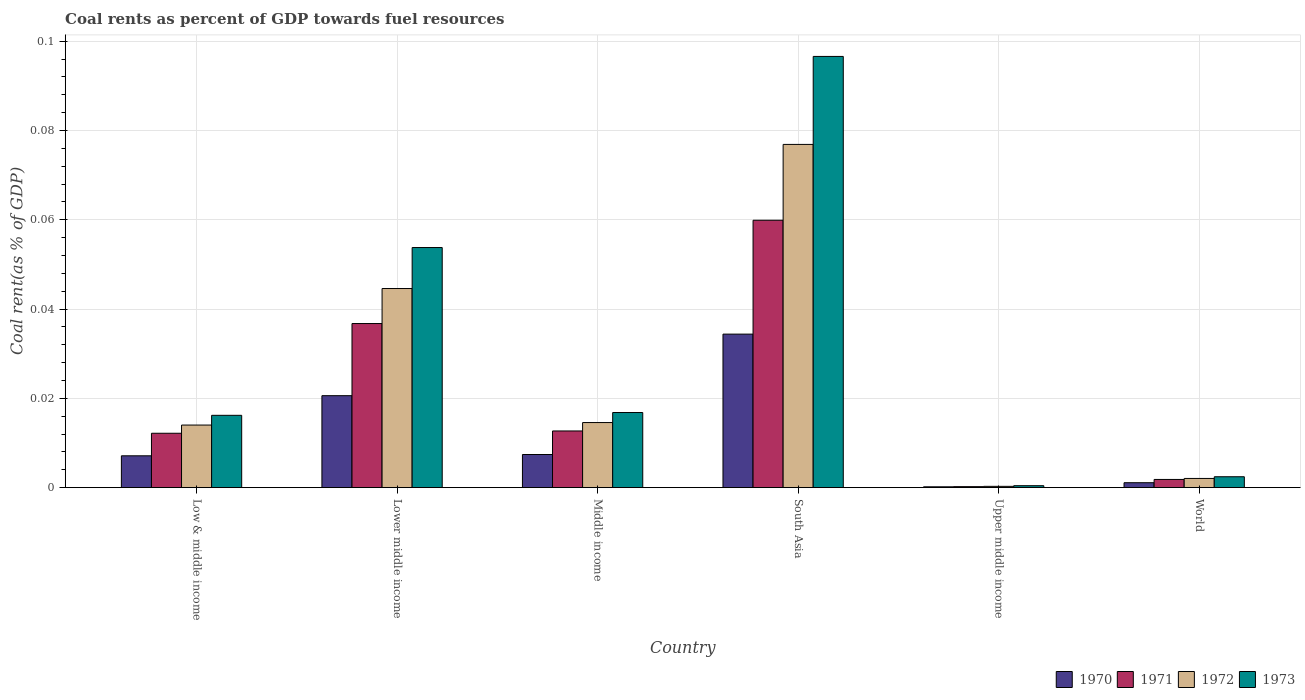How many different coloured bars are there?
Your response must be concise. 4. Are the number of bars per tick equal to the number of legend labels?
Provide a succinct answer. Yes. Are the number of bars on each tick of the X-axis equal?
Your answer should be compact. Yes. What is the label of the 5th group of bars from the left?
Keep it short and to the point. Upper middle income. What is the coal rent in 1970 in Lower middle income?
Make the answer very short. 0.02. Across all countries, what is the maximum coal rent in 1972?
Provide a succinct answer. 0.08. Across all countries, what is the minimum coal rent in 1973?
Your response must be concise. 0. In which country was the coal rent in 1973 minimum?
Offer a very short reply. Upper middle income. What is the total coal rent in 1971 in the graph?
Your response must be concise. 0.12. What is the difference between the coal rent in 1973 in Middle income and that in South Asia?
Keep it short and to the point. -0.08. What is the difference between the coal rent in 1972 in World and the coal rent in 1970 in South Asia?
Your response must be concise. -0.03. What is the average coal rent in 1971 per country?
Offer a very short reply. 0.02. What is the difference between the coal rent of/in 1971 and coal rent of/in 1970 in World?
Provide a succinct answer. 0. What is the ratio of the coal rent in 1971 in South Asia to that in World?
Your response must be concise. 32.69. Is the difference between the coal rent in 1971 in Lower middle income and Middle income greater than the difference between the coal rent in 1970 in Lower middle income and Middle income?
Your answer should be compact. Yes. What is the difference between the highest and the second highest coal rent in 1973?
Offer a terse response. 0.08. What is the difference between the highest and the lowest coal rent in 1971?
Provide a short and direct response. 0.06. Is the sum of the coal rent in 1970 in South Asia and Upper middle income greater than the maximum coal rent in 1973 across all countries?
Offer a terse response. No. Is it the case that in every country, the sum of the coal rent in 1972 and coal rent in 1970 is greater than the sum of coal rent in 1973 and coal rent in 1971?
Offer a very short reply. No. What does the 1st bar from the right in Middle income represents?
Provide a succinct answer. 1973. How many countries are there in the graph?
Your answer should be compact. 6. What is the difference between two consecutive major ticks on the Y-axis?
Offer a very short reply. 0.02. Does the graph contain any zero values?
Provide a short and direct response. No. How are the legend labels stacked?
Give a very brief answer. Horizontal. What is the title of the graph?
Give a very brief answer. Coal rents as percent of GDP towards fuel resources. What is the label or title of the X-axis?
Your answer should be compact. Country. What is the label or title of the Y-axis?
Make the answer very short. Coal rent(as % of GDP). What is the Coal rent(as % of GDP) of 1970 in Low & middle income?
Your answer should be compact. 0.01. What is the Coal rent(as % of GDP) in 1971 in Low & middle income?
Give a very brief answer. 0.01. What is the Coal rent(as % of GDP) of 1972 in Low & middle income?
Your response must be concise. 0.01. What is the Coal rent(as % of GDP) in 1973 in Low & middle income?
Make the answer very short. 0.02. What is the Coal rent(as % of GDP) in 1970 in Lower middle income?
Offer a very short reply. 0.02. What is the Coal rent(as % of GDP) in 1971 in Lower middle income?
Keep it short and to the point. 0.04. What is the Coal rent(as % of GDP) in 1972 in Lower middle income?
Provide a succinct answer. 0.04. What is the Coal rent(as % of GDP) of 1973 in Lower middle income?
Provide a short and direct response. 0.05. What is the Coal rent(as % of GDP) in 1970 in Middle income?
Give a very brief answer. 0.01. What is the Coal rent(as % of GDP) of 1971 in Middle income?
Offer a very short reply. 0.01. What is the Coal rent(as % of GDP) in 1972 in Middle income?
Provide a succinct answer. 0.01. What is the Coal rent(as % of GDP) of 1973 in Middle income?
Your response must be concise. 0.02. What is the Coal rent(as % of GDP) in 1970 in South Asia?
Keep it short and to the point. 0.03. What is the Coal rent(as % of GDP) in 1971 in South Asia?
Give a very brief answer. 0.06. What is the Coal rent(as % of GDP) of 1972 in South Asia?
Ensure brevity in your answer.  0.08. What is the Coal rent(as % of GDP) in 1973 in South Asia?
Provide a succinct answer. 0.1. What is the Coal rent(as % of GDP) of 1970 in Upper middle income?
Your response must be concise. 0. What is the Coal rent(as % of GDP) of 1971 in Upper middle income?
Provide a short and direct response. 0. What is the Coal rent(as % of GDP) of 1972 in Upper middle income?
Give a very brief answer. 0. What is the Coal rent(as % of GDP) of 1973 in Upper middle income?
Offer a very short reply. 0. What is the Coal rent(as % of GDP) of 1970 in World?
Offer a very short reply. 0. What is the Coal rent(as % of GDP) in 1971 in World?
Offer a terse response. 0. What is the Coal rent(as % of GDP) of 1972 in World?
Provide a succinct answer. 0. What is the Coal rent(as % of GDP) in 1973 in World?
Give a very brief answer. 0. Across all countries, what is the maximum Coal rent(as % of GDP) in 1970?
Provide a succinct answer. 0.03. Across all countries, what is the maximum Coal rent(as % of GDP) in 1971?
Keep it short and to the point. 0.06. Across all countries, what is the maximum Coal rent(as % of GDP) of 1972?
Your response must be concise. 0.08. Across all countries, what is the maximum Coal rent(as % of GDP) of 1973?
Keep it short and to the point. 0.1. Across all countries, what is the minimum Coal rent(as % of GDP) in 1970?
Provide a succinct answer. 0. Across all countries, what is the minimum Coal rent(as % of GDP) of 1971?
Your answer should be very brief. 0. Across all countries, what is the minimum Coal rent(as % of GDP) in 1972?
Keep it short and to the point. 0. Across all countries, what is the minimum Coal rent(as % of GDP) of 1973?
Offer a terse response. 0. What is the total Coal rent(as % of GDP) of 1970 in the graph?
Make the answer very short. 0.07. What is the total Coal rent(as % of GDP) in 1971 in the graph?
Provide a succinct answer. 0.12. What is the total Coal rent(as % of GDP) in 1972 in the graph?
Provide a short and direct response. 0.15. What is the total Coal rent(as % of GDP) in 1973 in the graph?
Your response must be concise. 0.19. What is the difference between the Coal rent(as % of GDP) in 1970 in Low & middle income and that in Lower middle income?
Provide a short and direct response. -0.01. What is the difference between the Coal rent(as % of GDP) of 1971 in Low & middle income and that in Lower middle income?
Provide a short and direct response. -0.02. What is the difference between the Coal rent(as % of GDP) in 1972 in Low & middle income and that in Lower middle income?
Your response must be concise. -0.03. What is the difference between the Coal rent(as % of GDP) in 1973 in Low & middle income and that in Lower middle income?
Give a very brief answer. -0.04. What is the difference between the Coal rent(as % of GDP) of 1970 in Low & middle income and that in Middle income?
Make the answer very short. -0. What is the difference between the Coal rent(as % of GDP) in 1971 in Low & middle income and that in Middle income?
Offer a terse response. -0. What is the difference between the Coal rent(as % of GDP) of 1972 in Low & middle income and that in Middle income?
Your response must be concise. -0. What is the difference between the Coal rent(as % of GDP) of 1973 in Low & middle income and that in Middle income?
Offer a very short reply. -0. What is the difference between the Coal rent(as % of GDP) of 1970 in Low & middle income and that in South Asia?
Give a very brief answer. -0.03. What is the difference between the Coal rent(as % of GDP) in 1971 in Low & middle income and that in South Asia?
Offer a very short reply. -0.05. What is the difference between the Coal rent(as % of GDP) in 1972 in Low & middle income and that in South Asia?
Offer a very short reply. -0.06. What is the difference between the Coal rent(as % of GDP) in 1973 in Low & middle income and that in South Asia?
Your answer should be compact. -0.08. What is the difference between the Coal rent(as % of GDP) of 1970 in Low & middle income and that in Upper middle income?
Ensure brevity in your answer.  0.01. What is the difference between the Coal rent(as % of GDP) of 1971 in Low & middle income and that in Upper middle income?
Your answer should be very brief. 0.01. What is the difference between the Coal rent(as % of GDP) in 1972 in Low & middle income and that in Upper middle income?
Your answer should be very brief. 0.01. What is the difference between the Coal rent(as % of GDP) in 1973 in Low & middle income and that in Upper middle income?
Your answer should be compact. 0.02. What is the difference between the Coal rent(as % of GDP) of 1970 in Low & middle income and that in World?
Give a very brief answer. 0.01. What is the difference between the Coal rent(as % of GDP) in 1971 in Low & middle income and that in World?
Provide a short and direct response. 0.01. What is the difference between the Coal rent(as % of GDP) of 1972 in Low & middle income and that in World?
Provide a succinct answer. 0.01. What is the difference between the Coal rent(as % of GDP) in 1973 in Low & middle income and that in World?
Provide a short and direct response. 0.01. What is the difference between the Coal rent(as % of GDP) in 1970 in Lower middle income and that in Middle income?
Your answer should be very brief. 0.01. What is the difference between the Coal rent(as % of GDP) in 1971 in Lower middle income and that in Middle income?
Ensure brevity in your answer.  0.02. What is the difference between the Coal rent(as % of GDP) of 1973 in Lower middle income and that in Middle income?
Your answer should be very brief. 0.04. What is the difference between the Coal rent(as % of GDP) of 1970 in Lower middle income and that in South Asia?
Keep it short and to the point. -0.01. What is the difference between the Coal rent(as % of GDP) of 1971 in Lower middle income and that in South Asia?
Your answer should be very brief. -0.02. What is the difference between the Coal rent(as % of GDP) in 1972 in Lower middle income and that in South Asia?
Ensure brevity in your answer.  -0.03. What is the difference between the Coal rent(as % of GDP) of 1973 in Lower middle income and that in South Asia?
Keep it short and to the point. -0.04. What is the difference between the Coal rent(as % of GDP) of 1970 in Lower middle income and that in Upper middle income?
Offer a very short reply. 0.02. What is the difference between the Coal rent(as % of GDP) in 1971 in Lower middle income and that in Upper middle income?
Make the answer very short. 0.04. What is the difference between the Coal rent(as % of GDP) in 1972 in Lower middle income and that in Upper middle income?
Provide a succinct answer. 0.04. What is the difference between the Coal rent(as % of GDP) of 1973 in Lower middle income and that in Upper middle income?
Provide a short and direct response. 0.05. What is the difference between the Coal rent(as % of GDP) of 1970 in Lower middle income and that in World?
Ensure brevity in your answer.  0.02. What is the difference between the Coal rent(as % of GDP) of 1971 in Lower middle income and that in World?
Ensure brevity in your answer.  0.03. What is the difference between the Coal rent(as % of GDP) in 1972 in Lower middle income and that in World?
Your answer should be compact. 0.04. What is the difference between the Coal rent(as % of GDP) in 1973 in Lower middle income and that in World?
Provide a succinct answer. 0.05. What is the difference between the Coal rent(as % of GDP) of 1970 in Middle income and that in South Asia?
Provide a short and direct response. -0.03. What is the difference between the Coal rent(as % of GDP) of 1971 in Middle income and that in South Asia?
Your response must be concise. -0.05. What is the difference between the Coal rent(as % of GDP) of 1972 in Middle income and that in South Asia?
Offer a terse response. -0.06. What is the difference between the Coal rent(as % of GDP) of 1973 in Middle income and that in South Asia?
Your answer should be very brief. -0.08. What is the difference between the Coal rent(as % of GDP) in 1970 in Middle income and that in Upper middle income?
Your response must be concise. 0.01. What is the difference between the Coal rent(as % of GDP) in 1971 in Middle income and that in Upper middle income?
Your response must be concise. 0.01. What is the difference between the Coal rent(as % of GDP) in 1972 in Middle income and that in Upper middle income?
Give a very brief answer. 0.01. What is the difference between the Coal rent(as % of GDP) in 1973 in Middle income and that in Upper middle income?
Offer a terse response. 0.02. What is the difference between the Coal rent(as % of GDP) of 1970 in Middle income and that in World?
Your answer should be compact. 0.01. What is the difference between the Coal rent(as % of GDP) in 1971 in Middle income and that in World?
Offer a terse response. 0.01. What is the difference between the Coal rent(as % of GDP) of 1972 in Middle income and that in World?
Make the answer very short. 0.01. What is the difference between the Coal rent(as % of GDP) in 1973 in Middle income and that in World?
Provide a succinct answer. 0.01. What is the difference between the Coal rent(as % of GDP) in 1970 in South Asia and that in Upper middle income?
Keep it short and to the point. 0.03. What is the difference between the Coal rent(as % of GDP) in 1971 in South Asia and that in Upper middle income?
Make the answer very short. 0.06. What is the difference between the Coal rent(as % of GDP) of 1972 in South Asia and that in Upper middle income?
Your answer should be compact. 0.08. What is the difference between the Coal rent(as % of GDP) in 1973 in South Asia and that in Upper middle income?
Make the answer very short. 0.1. What is the difference between the Coal rent(as % of GDP) in 1971 in South Asia and that in World?
Ensure brevity in your answer.  0.06. What is the difference between the Coal rent(as % of GDP) in 1972 in South Asia and that in World?
Offer a terse response. 0.07. What is the difference between the Coal rent(as % of GDP) of 1973 in South Asia and that in World?
Provide a short and direct response. 0.09. What is the difference between the Coal rent(as % of GDP) of 1970 in Upper middle income and that in World?
Ensure brevity in your answer.  -0. What is the difference between the Coal rent(as % of GDP) in 1971 in Upper middle income and that in World?
Give a very brief answer. -0. What is the difference between the Coal rent(as % of GDP) in 1972 in Upper middle income and that in World?
Your answer should be very brief. -0. What is the difference between the Coal rent(as % of GDP) of 1973 in Upper middle income and that in World?
Provide a succinct answer. -0. What is the difference between the Coal rent(as % of GDP) of 1970 in Low & middle income and the Coal rent(as % of GDP) of 1971 in Lower middle income?
Keep it short and to the point. -0.03. What is the difference between the Coal rent(as % of GDP) of 1970 in Low & middle income and the Coal rent(as % of GDP) of 1972 in Lower middle income?
Provide a succinct answer. -0.04. What is the difference between the Coal rent(as % of GDP) in 1970 in Low & middle income and the Coal rent(as % of GDP) in 1973 in Lower middle income?
Offer a terse response. -0.05. What is the difference between the Coal rent(as % of GDP) of 1971 in Low & middle income and the Coal rent(as % of GDP) of 1972 in Lower middle income?
Keep it short and to the point. -0.03. What is the difference between the Coal rent(as % of GDP) in 1971 in Low & middle income and the Coal rent(as % of GDP) in 1973 in Lower middle income?
Your answer should be compact. -0.04. What is the difference between the Coal rent(as % of GDP) in 1972 in Low & middle income and the Coal rent(as % of GDP) in 1973 in Lower middle income?
Give a very brief answer. -0.04. What is the difference between the Coal rent(as % of GDP) in 1970 in Low & middle income and the Coal rent(as % of GDP) in 1971 in Middle income?
Your answer should be compact. -0.01. What is the difference between the Coal rent(as % of GDP) in 1970 in Low & middle income and the Coal rent(as % of GDP) in 1972 in Middle income?
Give a very brief answer. -0.01. What is the difference between the Coal rent(as % of GDP) in 1970 in Low & middle income and the Coal rent(as % of GDP) in 1973 in Middle income?
Offer a very short reply. -0.01. What is the difference between the Coal rent(as % of GDP) of 1971 in Low & middle income and the Coal rent(as % of GDP) of 1972 in Middle income?
Offer a very short reply. -0. What is the difference between the Coal rent(as % of GDP) in 1971 in Low & middle income and the Coal rent(as % of GDP) in 1973 in Middle income?
Offer a terse response. -0. What is the difference between the Coal rent(as % of GDP) of 1972 in Low & middle income and the Coal rent(as % of GDP) of 1973 in Middle income?
Your answer should be compact. -0. What is the difference between the Coal rent(as % of GDP) in 1970 in Low & middle income and the Coal rent(as % of GDP) in 1971 in South Asia?
Your answer should be very brief. -0.05. What is the difference between the Coal rent(as % of GDP) in 1970 in Low & middle income and the Coal rent(as % of GDP) in 1972 in South Asia?
Offer a very short reply. -0.07. What is the difference between the Coal rent(as % of GDP) of 1970 in Low & middle income and the Coal rent(as % of GDP) of 1973 in South Asia?
Make the answer very short. -0.09. What is the difference between the Coal rent(as % of GDP) of 1971 in Low & middle income and the Coal rent(as % of GDP) of 1972 in South Asia?
Provide a succinct answer. -0.06. What is the difference between the Coal rent(as % of GDP) in 1971 in Low & middle income and the Coal rent(as % of GDP) in 1973 in South Asia?
Offer a very short reply. -0.08. What is the difference between the Coal rent(as % of GDP) of 1972 in Low & middle income and the Coal rent(as % of GDP) of 1973 in South Asia?
Offer a very short reply. -0.08. What is the difference between the Coal rent(as % of GDP) of 1970 in Low & middle income and the Coal rent(as % of GDP) of 1971 in Upper middle income?
Your response must be concise. 0.01. What is the difference between the Coal rent(as % of GDP) of 1970 in Low & middle income and the Coal rent(as % of GDP) of 1972 in Upper middle income?
Keep it short and to the point. 0.01. What is the difference between the Coal rent(as % of GDP) of 1970 in Low & middle income and the Coal rent(as % of GDP) of 1973 in Upper middle income?
Offer a very short reply. 0.01. What is the difference between the Coal rent(as % of GDP) in 1971 in Low & middle income and the Coal rent(as % of GDP) in 1972 in Upper middle income?
Offer a terse response. 0.01. What is the difference between the Coal rent(as % of GDP) in 1971 in Low & middle income and the Coal rent(as % of GDP) in 1973 in Upper middle income?
Ensure brevity in your answer.  0.01. What is the difference between the Coal rent(as % of GDP) in 1972 in Low & middle income and the Coal rent(as % of GDP) in 1973 in Upper middle income?
Make the answer very short. 0.01. What is the difference between the Coal rent(as % of GDP) in 1970 in Low & middle income and the Coal rent(as % of GDP) in 1971 in World?
Ensure brevity in your answer.  0.01. What is the difference between the Coal rent(as % of GDP) of 1970 in Low & middle income and the Coal rent(as % of GDP) of 1972 in World?
Ensure brevity in your answer.  0.01. What is the difference between the Coal rent(as % of GDP) in 1970 in Low & middle income and the Coal rent(as % of GDP) in 1973 in World?
Your answer should be compact. 0. What is the difference between the Coal rent(as % of GDP) in 1971 in Low & middle income and the Coal rent(as % of GDP) in 1972 in World?
Provide a short and direct response. 0.01. What is the difference between the Coal rent(as % of GDP) in 1971 in Low & middle income and the Coal rent(as % of GDP) in 1973 in World?
Offer a very short reply. 0.01. What is the difference between the Coal rent(as % of GDP) of 1972 in Low & middle income and the Coal rent(as % of GDP) of 1973 in World?
Offer a very short reply. 0.01. What is the difference between the Coal rent(as % of GDP) in 1970 in Lower middle income and the Coal rent(as % of GDP) in 1971 in Middle income?
Provide a short and direct response. 0.01. What is the difference between the Coal rent(as % of GDP) in 1970 in Lower middle income and the Coal rent(as % of GDP) in 1972 in Middle income?
Your answer should be very brief. 0.01. What is the difference between the Coal rent(as % of GDP) of 1970 in Lower middle income and the Coal rent(as % of GDP) of 1973 in Middle income?
Provide a short and direct response. 0. What is the difference between the Coal rent(as % of GDP) of 1971 in Lower middle income and the Coal rent(as % of GDP) of 1972 in Middle income?
Provide a succinct answer. 0.02. What is the difference between the Coal rent(as % of GDP) in 1971 in Lower middle income and the Coal rent(as % of GDP) in 1973 in Middle income?
Offer a very short reply. 0.02. What is the difference between the Coal rent(as % of GDP) in 1972 in Lower middle income and the Coal rent(as % of GDP) in 1973 in Middle income?
Give a very brief answer. 0.03. What is the difference between the Coal rent(as % of GDP) in 1970 in Lower middle income and the Coal rent(as % of GDP) in 1971 in South Asia?
Provide a short and direct response. -0.04. What is the difference between the Coal rent(as % of GDP) in 1970 in Lower middle income and the Coal rent(as % of GDP) in 1972 in South Asia?
Offer a very short reply. -0.06. What is the difference between the Coal rent(as % of GDP) of 1970 in Lower middle income and the Coal rent(as % of GDP) of 1973 in South Asia?
Offer a very short reply. -0.08. What is the difference between the Coal rent(as % of GDP) in 1971 in Lower middle income and the Coal rent(as % of GDP) in 1972 in South Asia?
Make the answer very short. -0.04. What is the difference between the Coal rent(as % of GDP) of 1971 in Lower middle income and the Coal rent(as % of GDP) of 1973 in South Asia?
Your response must be concise. -0.06. What is the difference between the Coal rent(as % of GDP) of 1972 in Lower middle income and the Coal rent(as % of GDP) of 1973 in South Asia?
Provide a succinct answer. -0.05. What is the difference between the Coal rent(as % of GDP) of 1970 in Lower middle income and the Coal rent(as % of GDP) of 1971 in Upper middle income?
Offer a terse response. 0.02. What is the difference between the Coal rent(as % of GDP) of 1970 in Lower middle income and the Coal rent(as % of GDP) of 1972 in Upper middle income?
Provide a succinct answer. 0.02. What is the difference between the Coal rent(as % of GDP) in 1970 in Lower middle income and the Coal rent(as % of GDP) in 1973 in Upper middle income?
Keep it short and to the point. 0.02. What is the difference between the Coal rent(as % of GDP) of 1971 in Lower middle income and the Coal rent(as % of GDP) of 1972 in Upper middle income?
Ensure brevity in your answer.  0.04. What is the difference between the Coal rent(as % of GDP) of 1971 in Lower middle income and the Coal rent(as % of GDP) of 1973 in Upper middle income?
Provide a succinct answer. 0.04. What is the difference between the Coal rent(as % of GDP) in 1972 in Lower middle income and the Coal rent(as % of GDP) in 1973 in Upper middle income?
Your response must be concise. 0.04. What is the difference between the Coal rent(as % of GDP) in 1970 in Lower middle income and the Coal rent(as % of GDP) in 1971 in World?
Ensure brevity in your answer.  0.02. What is the difference between the Coal rent(as % of GDP) of 1970 in Lower middle income and the Coal rent(as % of GDP) of 1972 in World?
Offer a terse response. 0.02. What is the difference between the Coal rent(as % of GDP) in 1970 in Lower middle income and the Coal rent(as % of GDP) in 1973 in World?
Ensure brevity in your answer.  0.02. What is the difference between the Coal rent(as % of GDP) in 1971 in Lower middle income and the Coal rent(as % of GDP) in 1972 in World?
Your response must be concise. 0.03. What is the difference between the Coal rent(as % of GDP) of 1971 in Lower middle income and the Coal rent(as % of GDP) of 1973 in World?
Your answer should be very brief. 0.03. What is the difference between the Coal rent(as % of GDP) of 1972 in Lower middle income and the Coal rent(as % of GDP) of 1973 in World?
Offer a terse response. 0.04. What is the difference between the Coal rent(as % of GDP) in 1970 in Middle income and the Coal rent(as % of GDP) in 1971 in South Asia?
Your answer should be compact. -0.05. What is the difference between the Coal rent(as % of GDP) of 1970 in Middle income and the Coal rent(as % of GDP) of 1972 in South Asia?
Make the answer very short. -0.07. What is the difference between the Coal rent(as % of GDP) of 1970 in Middle income and the Coal rent(as % of GDP) of 1973 in South Asia?
Your answer should be compact. -0.09. What is the difference between the Coal rent(as % of GDP) of 1971 in Middle income and the Coal rent(as % of GDP) of 1972 in South Asia?
Ensure brevity in your answer.  -0.06. What is the difference between the Coal rent(as % of GDP) of 1971 in Middle income and the Coal rent(as % of GDP) of 1973 in South Asia?
Your answer should be compact. -0.08. What is the difference between the Coal rent(as % of GDP) of 1972 in Middle income and the Coal rent(as % of GDP) of 1973 in South Asia?
Make the answer very short. -0.08. What is the difference between the Coal rent(as % of GDP) of 1970 in Middle income and the Coal rent(as % of GDP) of 1971 in Upper middle income?
Ensure brevity in your answer.  0.01. What is the difference between the Coal rent(as % of GDP) of 1970 in Middle income and the Coal rent(as % of GDP) of 1972 in Upper middle income?
Provide a short and direct response. 0.01. What is the difference between the Coal rent(as % of GDP) in 1970 in Middle income and the Coal rent(as % of GDP) in 1973 in Upper middle income?
Your response must be concise. 0.01. What is the difference between the Coal rent(as % of GDP) of 1971 in Middle income and the Coal rent(as % of GDP) of 1972 in Upper middle income?
Offer a terse response. 0.01. What is the difference between the Coal rent(as % of GDP) in 1971 in Middle income and the Coal rent(as % of GDP) in 1973 in Upper middle income?
Give a very brief answer. 0.01. What is the difference between the Coal rent(as % of GDP) of 1972 in Middle income and the Coal rent(as % of GDP) of 1973 in Upper middle income?
Give a very brief answer. 0.01. What is the difference between the Coal rent(as % of GDP) in 1970 in Middle income and the Coal rent(as % of GDP) in 1971 in World?
Offer a terse response. 0.01. What is the difference between the Coal rent(as % of GDP) in 1970 in Middle income and the Coal rent(as % of GDP) in 1972 in World?
Provide a succinct answer. 0.01. What is the difference between the Coal rent(as % of GDP) in 1970 in Middle income and the Coal rent(as % of GDP) in 1973 in World?
Your answer should be very brief. 0.01. What is the difference between the Coal rent(as % of GDP) in 1971 in Middle income and the Coal rent(as % of GDP) in 1972 in World?
Your answer should be compact. 0.01. What is the difference between the Coal rent(as % of GDP) of 1971 in Middle income and the Coal rent(as % of GDP) of 1973 in World?
Offer a terse response. 0.01. What is the difference between the Coal rent(as % of GDP) in 1972 in Middle income and the Coal rent(as % of GDP) in 1973 in World?
Provide a short and direct response. 0.01. What is the difference between the Coal rent(as % of GDP) of 1970 in South Asia and the Coal rent(as % of GDP) of 1971 in Upper middle income?
Ensure brevity in your answer.  0.03. What is the difference between the Coal rent(as % of GDP) in 1970 in South Asia and the Coal rent(as % of GDP) in 1972 in Upper middle income?
Offer a terse response. 0.03. What is the difference between the Coal rent(as % of GDP) of 1970 in South Asia and the Coal rent(as % of GDP) of 1973 in Upper middle income?
Give a very brief answer. 0.03. What is the difference between the Coal rent(as % of GDP) in 1971 in South Asia and the Coal rent(as % of GDP) in 1972 in Upper middle income?
Keep it short and to the point. 0.06. What is the difference between the Coal rent(as % of GDP) in 1971 in South Asia and the Coal rent(as % of GDP) in 1973 in Upper middle income?
Provide a succinct answer. 0.06. What is the difference between the Coal rent(as % of GDP) in 1972 in South Asia and the Coal rent(as % of GDP) in 1973 in Upper middle income?
Make the answer very short. 0.08. What is the difference between the Coal rent(as % of GDP) of 1970 in South Asia and the Coal rent(as % of GDP) of 1971 in World?
Your answer should be very brief. 0.03. What is the difference between the Coal rent(as % of GDP) in 1970 in South Asia and the Coal rent(as % of GDP) in 1972 in World?
Make the answer very short. 0.03. What is the difference between the Coal rent(as % of GDP) in 1970 in South Asia and the Coal rent(as % of GDP) in 1973 in World?
Your answer should be very brief. 0.03. What is the difference between the Coal rent(as % of GDP) of 1971 in South Asia and the Coal rent(as % of GDP) of 1972 in World?
Provide a short and direct response. 0.06. What is the difference between the Coal rent(as % of GDP) of 1971 in South Asia and the Coal rent(as % of GDP) of 1973 in World?
Your answer should be very brief. 0.06. What is the difference between the Coal rent(as % of GDP) of 1972 in South Asia and the Coal rent(as % of GDP) of 1973 in World?
Your response must be concise. 0.07. What is the difference between the Coal rent(as % of GDP) of 1970 in Upper middle income and the Coal rent(as % of GDP) of 1971 in World?
Provide a succinct answer. -0. What is the difference between the Coal rent(as % of GDP) of 1970 in Upper middle income and the Coal rent(as % of GDP) of 1972 in World?
Offer a terse response. -0. What is the difference between the Coal rent(as % of GDP) of 1970 in Upper middle income and the Coal rent(as % of GDP) of 1973 in World?
Your answer should be very brief. -0. What is the difference between the Coal rent(as % of GDP) of 1971 in Upper middle income and the Coal rent(as % of GDP) of 1972 in World?
Make the answer very short. -0. What is the difference between the Coal rent(as % of GDP) in 1971 in Upper middle income and the Coal rent(as % of GDP) in 1973 in World?
Provide a succinct answer. -0. What is the difference between the Coal rent(as % of GDP) in 1972 in Upper middle income and the Coal rent(as % of GDP) in 1973 in World?
Your response must be concise. -0. What is the average Coal rent(as % of GDP) in 1970 per country?
Give a very brief answer. 0.01. What is the average Coal rent(as % of GDP) in 1971 per country?
Offer a terse response. 0.02. What is the average Coal rent(as % of GDP) in 1972 per country?
Provide a short and direct response. 0.03. What is the average Coal rent(as % of GDP) of 1973 per country?
Ensure brevity in your answer.  0.03. What is the difference between the Coal rent(as % of GDP) of 1970 and Coal rent(as % of GDP) of 1971 in Low & middle income?
Give a very brief answer. -0.01. What is the difference between the Coal rent(as % of GDP) in 1970 and Coal rent(as % of GDP) in 1972 in Low & middle income?
Offer a terse response. -0.01. What is the difference between the Coal rent(as % of GDP) of 1970 and Coal rent(as % of GDP) of 1973 in Low & middle income?
Ensure brevity in your answer.  -0.01. What is the difference between the Coal rent(as % of GDP) in 1971 and Coal rent(as % of GDP) in 1972 in Low & middle income?
Your answer should be compact. -0. What is the difference between the Coal rent(as % of GDP) in 1971 and Coal rent(as % of GDP) in 1973 in Low & middle income?
Give a very brief answer. -0. What is the difference between the Coal rent(as % of GDP) of 1972 and Coal rent(as % of GDP) of 1973 in Low & middle income?
Make the answer very short. -0. What is the difference between the Coal rent(as % of GDP) of 1970 and Coal rent(as % of GDP) of 1971 in Lower middle income?
Your response must be concise. -0.02. What is the difference between the Coal rent(as % of GDP) in 1970 and Coal rent(as % of GDP) in 1972 in Lower middle income?
Make the answer very short. -0.02. What is the difference between the Coal rent(as % of GDP) of 1970 and Coal rent(as % of GDP) of 1973 in Lower middle income?
Provide a short and direct response. -0.03. What is the difference between the Coal rent(as % of GDP) in 1971 and Coal rent(as % of GDP) in 1972 in Lower middle income?
Make the answer very short. -0.01. What is the difference between the Coal rent(as % of GDP) of 1971 and Coal rent(as % of GDP) of 1973 in Lower middle income?
Provide a short and direct response. -0.02. What is the difference between the Coal rent(as % of GDP) of 1972 and Coal rent(as % of GDP) of 1973 in Lower middle income?
Your answer should be compact. -0.01. What is the difference between the Coal rent(as % of GDP) of 1970 and Coal rent(as % of GDP) of 1971 in Middle income?
Keep it short and to the point. -0.01. What is the difference between the Coal rent(as % of GDP) in 1970 and Coal rent(as % of GDP) in 1972 in Middle income?
Offer a very short reply. -0.01. What is the difference between the Coal rent(as % of GDP) of 1970 and Coal rent(as % of GDP) of 1973 in Middle income?
Make the answer very short. -0.01. What is the difference between the Coal rent(as % of GDP) of 1971 and Coal rent(as % of GDP) of 1972 in Middle income?
Give a very brief answer. -0. What is the difference between the Coal rent(as % of GDP) in 1971 and Coal rent(as % of GDP) in 1973 in Middle income?
Offer a very short reply. -0. What is the difference between the Coal rent(as % of GDP) in 1972 and Coal rent(as % of GDP) in 1973 in Middle income?
Offer a very short reply. -0. What is the difference between the Coal rent(as % of GDP) in 1970 and Coal rent(as % of GDP) in 1971 in South Asia?
Keep it short and to the point. -0.03. What is the difference between the Coal rent(as % of GDP) of 1970 and Coal rent(as % of GDP) of 1972 in South Asia?
Provide a succinct answer. -0.04. What is the difference between the Coal rent(as % of GDP) in 1970 and Coal rent(as % of GDP) in 1973 in South Asia?
Give a very brief answer. -0.06. What is the difference between the Coal rent(as % of GDP) in 1971 and Coal rent(as % of GDP) in 1972 in South Asia?
Offer a terse response. -0.02. What is the difference between the Coal rent(as % of GDP) in 1971 and Coal rent(as % of GDP) in 1973 in South Asia?
Your answer should be very brief. -0.04. What is the difference between the Coal rent(as % of GDP) of 1972 and Coal rent(as % of GDP) of 1973 in South Asia?
Your answer should be very brief. -0.02. What is the difference between the Coal rent(as % of GDP) of 1970 and Coal rent(as % of GDP) of 1971 in Upper middle income?
Your answer should be compact. -0. What is the difference between the Coal rent(as % of GDP) of 1970 and Coal rent(as % of GDP) of 1972 in Upper middle income?
Offer a terse response. -0. What is the difference between the Coal rent(as % of GDP) in 1970 and Coal rent(as % of GDP) in 1973 in Upper middle income?
Ensure brevity in your answer.  -0. What is the difference between the Coal rent(as % of GDP) of 1971 and Coal rent(as % of GDP) of 1972 in Upper middle income?
Keep it short and to the point. -0. What is the difference between the Coal rent(as % of GDP) of 1971 and Coal rent(as % of GDP) of 1973 in Upper middle income?
Ensure brevity in your answer.  -0. What is the difference between the Coal rent(as % of GDP) of 1972 and Coal rent(as % of GDP) of 1973 in Upper middle income?
Provide a short and direct response. -0. What is the difference between the Coal rent(as % of GDP) in 1970 and Coal rent(as % of GDP) in 1971 in World?
Ensure brevity in your answer.  -0. What is the difference between the Coal rent(as % of GDP) in 1970 and Coal rent(as % of GDP) in 1972 in World?
Provide a short and direct response. -0. What is the difference between the Coal rent(as % of GDP) in 1970 and Coal rent(as % of GDP) in 1973 in World?
Your answer should be compact. -0. What is the difference between the Coal rent(as % of GDP) in 1971 and Coal rent(as % of GDP) in 1972 in World?
Give a very brief answer. -0. What is the difference between the Coal rent(as % of GDP) of 1971 and Coal rent(as % of GDP) of 1973 in World?
Ensure brevity in your answer.  -0. What is the difference between the Coal rent(as % of GDP) of 1972 and Coal rent(as % of GDP) of 1973 in World?
Provide a succinct answer. -0. What is the ratio of the Coal rent(as % of GDP) in 1970 in Low & middle income to that in Lower middle income?
Give a very brief answer. 0.35. What is the ratio of the Coal rent(as % of GDP) in 1971 in Low & middle income to that in Lower middle income?
Provide a short and direct response. 0.33. What is the ratio of the Coal rent(as % of GDP) of 1972 in Low & middle income to that in Lower middle income?
Keep it short and to the point. 0.31. What is the ratio of the Coal rent(as % of GDP) of 1973 in Low & middle income to that in Lower middle income?
Keep it short and to the point. 0.3. What is the ratio of the Coal rent(as % of GDP) in 1970 in Low & middle income to that in Middle income?
Provide a short and direct response. 0.96. What is the ratio of the Coal rent(as % of GDP) of 1971 in Low & middle income to that in Middle income?
Give a very brief answer. 0.96. What is the ratio of the Coal rent(as % of GDP) of 1972 in Low & middle income to that in Middle income?
Make the answer very short. 0.96. What is the ratio of the Coal rent(as % of GDP) of 1973 in Low & middle income to that in Middle income?
Give a very brief answer. 0.96. What is the ratio of the Coal rent(as % of GDP) of 1970 in Low & middle income to that in South Asia?
Make the answer very short. 0.21. What is the ratio of the Coal rent(as % of GDP) of 1971 in Low & middle income to that in South Asia?
Your response must be concise. 0.2. What is the ratio of the Coal rent(as % of GDP) in 1972 in Low & middle income to that in South Asia?
Offer a very short reply. 0.18. What is the ratio of the Coal rent(as % of GDP) in 1973 in Low & middle income to that in South Asia?
Provide a short and direct response. 0.17. What is the ratio of the Coal rent(as % of GDP) of 1970 in Low & middle income to that in Upper middle income?
Keep it short and to the point. 38.77. What is the ratio of the Coal rent(as % of GDP) of 1971 in Low & middle income to that in Upper middle income?
Your answer should be compact. 55.66. What is the ratio of the Coal rent(as % of GDP) of 1972 in Low & middle income to that in Upper middle income?
Offer a very short reply. 49.28. What is the ratio of the Coal rent(as % of GDP) in 1973 in Low & middle income to that in Upper middle income?
Keep it short and to the point. 37.59. What is the ratio of the Coal rent(as % of GDP) of 1970 in Low & middle income to that in World?
Your answer should be very brief. 6.48. What is the ratio of the Coal rent(as % of GDP) in 1971 in Low & middle income to that in World?
Your answer should be compact. 6.65. What is the ratio of the Coal rent(as % of GDP) of 1972 in Low & middle income to that in World?
Your answer should be compact. 6.82. What is the ratio of the Coal rent(as % of GDP) in 1973 in Low & middle income to that in World?
Provide a short and direct response. 6.65. What is the ratio of the Coal rent(as % of GDP) in 1970 in Lower middle income to that in Middle income?
Your answer should be very brief. 2.78. What is the ratio of the Coal rent(as % of GDP) of 1971 in Lower middle income to that in Middle income?
Make the answer very short. 2.9. What is the ratio of the Coal rent(as % of GDP) of 1972 in Lower middle income to that in Middle income?
Offer a very short reply. 3.06. What is the ratio of the Coal rent(as % of GDP) in 1973 in Lower middle income to that in Middle income?
Provide a succinct answer. 3.2. What is the ratio of the Coal rent(as % of GDP) in 1970 in Lower middle income to that in South Asia?
Provide a succinct answer. 0.6. What is the ratio of the Coal rent(as % of GDP) of 1971 in Lower middle income to that in South Asia?
Provide a short and direct response. 0.61. What is the ratio of the Coal rent(as % of GDP) in 1972 in Lower middle income to that in South Asia?
Ensure brevity in your answer.  0.58. What is the ratio of the Coal rent(as % of GDP) of 1973 in Lower middle income to that in South Asia?
Provide a short and direct response. 0.56. What is the ratio of the Coal rent(as % of GDP) in 1970 in Lower middle income to that in Upper middle income?
Offer a very short reply. 112.03. What is the ratio of the Coal rent(as % of GDP) of 1971 in Lower middle income to that in Upper middle income?
Your response must be concise. 167.98. What is the ratio of the Coal rent(as % of GDP) in 1972 in Lower middle income to that in Upper middle income?
Offer a very short reply. 156.82. What is the ratio of the Coal rent(as % of GDP) in 1973 in Lower middle income to that in Upper middle income?
Provide a succinct answer. 124.82. What is the ratio of the Coal rent(as % of GDP) in 1970 in Lower middle income to that in World?
Provide a succinct answer. 18.71. What is the ratio of the Coal rent(as % of GDP) in 1971 in Lower middle income to that in World?
Offer a very short reply. 20.06. What is the ratio of the Coal rent(as % of GDP) of 1972 in Lower middle income to that in World?
Give a very brief answer. 21.7. What is the ratio of the Coal rent(as % of GDP) in 1973 in Lower middle income to that in World?
Provide a succinct answer. 22.07. What is the ratio of the Coal rent(as % of GDP) in 1970 in Middle income to that in South Asia?
Make the answer very short. 0.22. What is the ratio of the Coal rent(as % of GDP) in 1971 in Middle income to that in South Asia?
Make the answer very short. 0.21. What is the ratio of the Coal rent(as % of GDP) in 1972 in Middle income to that in South Asia?
Give a very brief answer. 0.19. What is the ratio of the Coal rent(as % of GDP) of 1973 in Middle income to that in South Asia?
Your response must be concise. 0.17. What is the ratio of the Coal rent(as % of GDP) in 1970 in Middle income to that in Upper middle income?
Provide a short and direct response. 40.36. What is the ratio of the Coal rent(as % of GDP) of 1971 in Middle income to that in Upper middle income?
Offer a terse response. 58.01. What is the ratio of the Coal rent(as % of GDP) of 1972 in Middle income to that in Upper middle income?
Keep it short and to the point. 51.25. What is the ratio of the Coal rent(as % of GDP) of 1973 in Middle income to that in Upper middle income?
Make the answer very short. 39.04. What is the ratio of the Coal rent(as % of GDP) of 1970 in Middle income to that in World?
Give a very brief answer. 6.74. What is the ratio of the Coal rent(as % of GDP) in 1971 in Middle income to that in World?
Give a very brief answer. 6.93. What is the ratio of the Coal rent(as % of GDP) in 1972 in Middle income to that in World?
Your answer should be compact. 7.09. What is the ratio of the Coal rent(as % of GDP) in 1973 in Middle income to that in World?
Give a very brief answer. 6.91. What is the ratio of the Coal rent(as % of GDP) of 1970 in South Asia to that in Upper middle income?
Offer a terse response. 187.05. What is the ratio of the Coal rent(as % of GDP) in 1971 in South Asia to that in Upper middle income?
Your answer should be compact. 273.74. What is the ratio of the Coal rent(as % of GDP) in 1972 in South Asia to that in Upper middle income?
Your response must be concise. 270.32. What is the ratio of the Coal rent(as % of GDP) of 1973 in South Asia to that in Upper middle income?
Provide a short and direct response. 224.18. What is the ratio of the Coal rent(as % of GDP) of 1970 in South Asia to that in World?
Offer a terse response. 31.24. What is the ratio of the Coal rent(as % of GDP) of 1971 in South Asia to that in World?
Provide a short and direct response. 32.69. What is the ratio of the Coal rent(as % of GDP) of 1972 in South Asia to that in World?
Ensure brevity in your answer.  37.41. What is the ratio of the Coal rent(as % of GDP) of 1973 in South Asia to that in World?
Your answer should be very brief. 39.65. What is the ratio of the Coal rent(as % of GDP) in 1970 in Upper middle income to that in World?
Keep it short and to the point. 0.17. What is the ratio of the Coal rent(as % of GDP) of 1971 in Upper middle income to that in World?
Your answer should be compact. 0.12. What is the ratio of the Coal rent(as % of GDP) of 1972 in Upper middle income to that in World?
Your answer should be compact. 0.14. What is the ratio of the Coal rent(as % of GDP) of 1973 in Upper middle income to that in World?
Offer a terse response. 0.18. What is the difference between the highest and the second highest Coal rent(as % of GDP) of 1970?
Give a very brief answer. 0.01. What is the difference between the highest and the second highest Coal rent(as % of GDP) in 1971?
Offer a terse response. 0.02. What is the difference between the highest and the second highest Coal rent(as % of GDP) in 1972?
Ensure brevity in your answer.  0.03. What is the difference between the highest and the second highest Coal rent(as % of GDP) in 1973?
Provide a short and direct response. 0.04. What is the difference between the highest and the lowest Coal rent(as % of GDP) in 1970?
Your answer should be very brief. 0.03. What is the difference between the highest and the lowest Coal rent(as % of GDP) in 1971?
Make the answer very short. 0.06. What is the difference between the highest and the lowest Coal rent(as % of GDP) of 1972?
Keep it short and to the point. 0.08. What is the difference between the highest and the lowest Coal rent(as % of GDP) of 1973?
Offer a terse response. 0.1. 